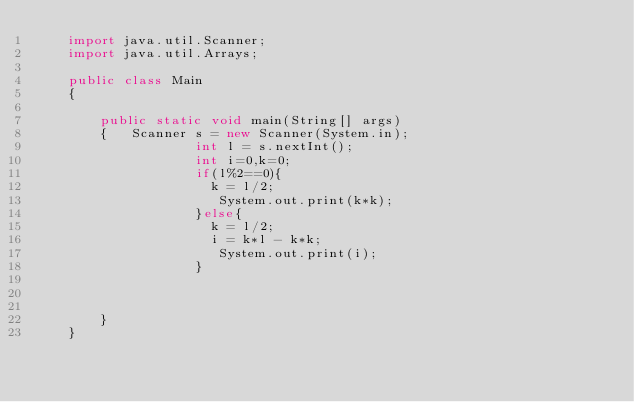<code> <loc_0><loc_0><loc_500><loc_500><_Java_>    import java.util.Scanner;
    import java.util.Arrays;
     
    public class Main
    {
     
    	public static void main(String[] args)
    	{	Scanner s = new Scanner(System.in);
                    int l = s.nextInt();
                    int i=0,k=0;
                    if(l%2==0){
                      k = l/2;
                       System.out.print(k*k);
                    }else{
                      k = l/2;
                      i = k*l - k*k;
                       System.out.print(i);
                    }
                    
                         
                    
    	}
    }</code> 